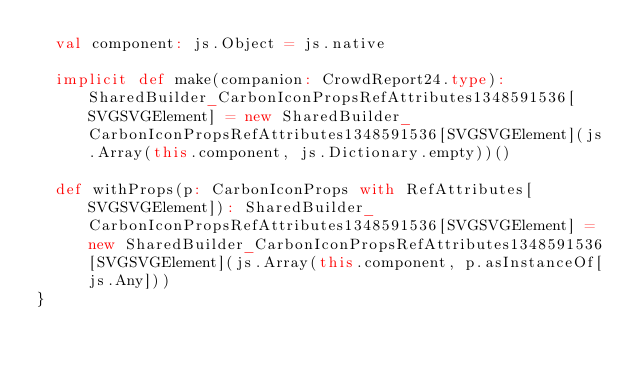Convert code to text. <code><loc_0><loc_0><loc_500><loc_500><_Scala_>  val component: js.Object = js.native
  
  implicit def make(companion: CrowdReport24.type): SharedBuilder_CarbonIconPropsRefAttributes1348591536[SVGSVGElement] = new SharedBuilder_CarbonIconPropsRefAttributes1348591536[SVGSVGElement](js.Array(this.component, js.Dictionary.empty))()
  
  def withProps(p: CarbonIconProps with RefAttributes[SVGSVGElement]): SharedBuilder_CarbonIconPropsRefAttributes1348591536[SVGSVGElement] = new SharedBuilder_CarbonIconPropsRefAttributes1348591536[SVGSVGElement](js.Array(this.component, p.asInstanceOf[js.Any]))
}
</code> 